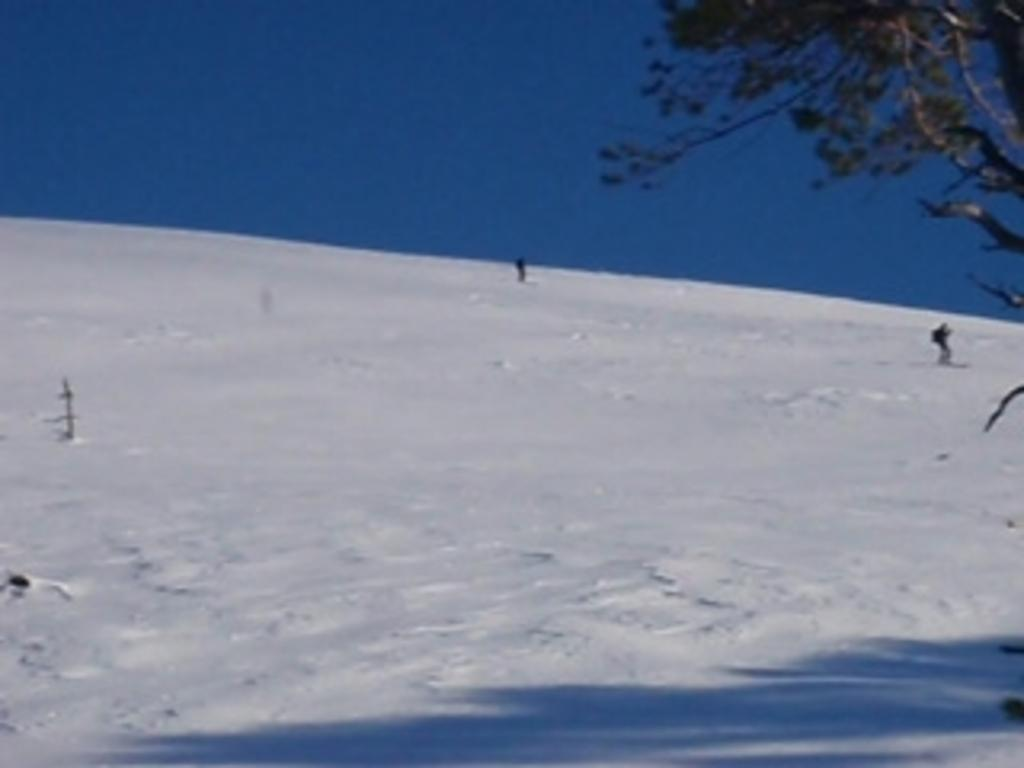What is the condition of the ground in the image? The ground is covered with snow. What natural element can be seen in the image? There is a tree in the image. What is the condition of the sky in the image? The sky is clear in the image. What word is written on the bread in the image? There is no bread present in the image, and therefore no words can be read on it. 